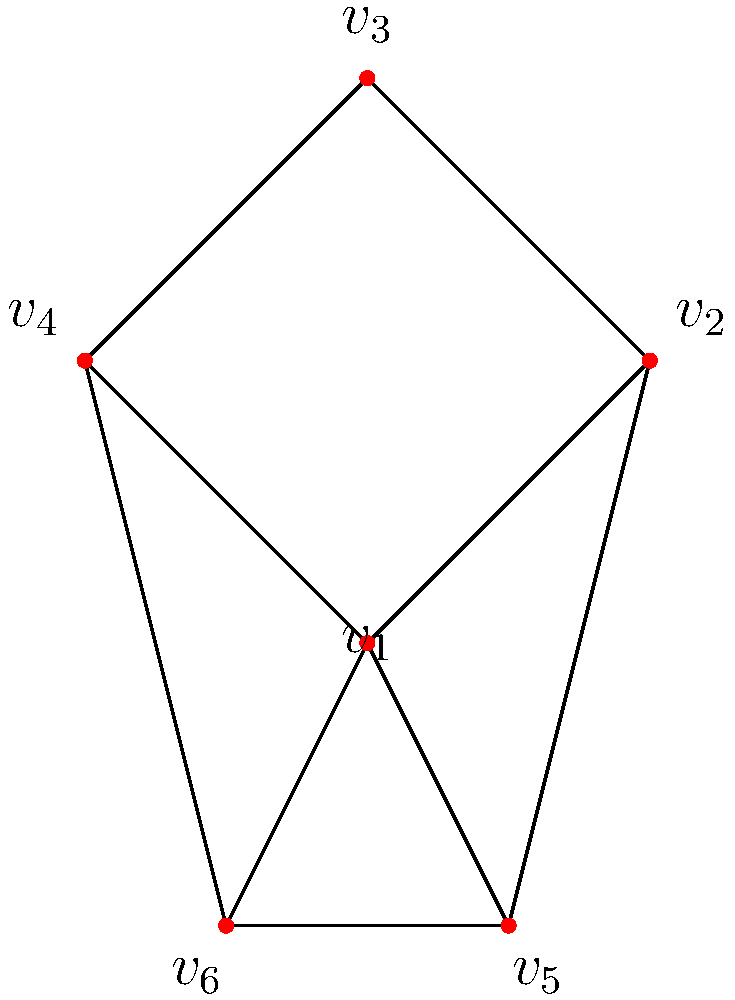In a multiplayer game, you and your sibling are designing a map with different territories. The map is represented by the graph above, where each vertex represents a territory. Adjacent territories must have different colors to distinguish them clearly. What is the minimum number of colors needed to properly color this map? To solve this problem, we'll use the concept of graph coloring:

1. First, observe that vertices $v_1$, $v_2$, $v_3$, and $v_4$ form a cycle of length 4. This means we need at least 2 colors.

2. Now, let's try to color the graph with 2 colors:
   - Assign color 1 to $v_1$ and $v_3$
   - Assign color 2 to $v_2$ and $v_4$

3. Next, we need to color $v_5$:
   - It's adjacent to $v_1$ (color 1), so it must be color 2

4. Finally, we need to color $v_6$:
   - It's adjacent to $v_3$ (color 1) and $v_5$ (color 2)
   - We can't use either color 1 or 2

5. Therefore, we need to introduce a third color for $v_6$

6. Check that this coloring satisfies all constraints:
   - No two adjacent vertices have the same color

Thus, the minimum number of colors needed is 3.
Answer: 3 colors 